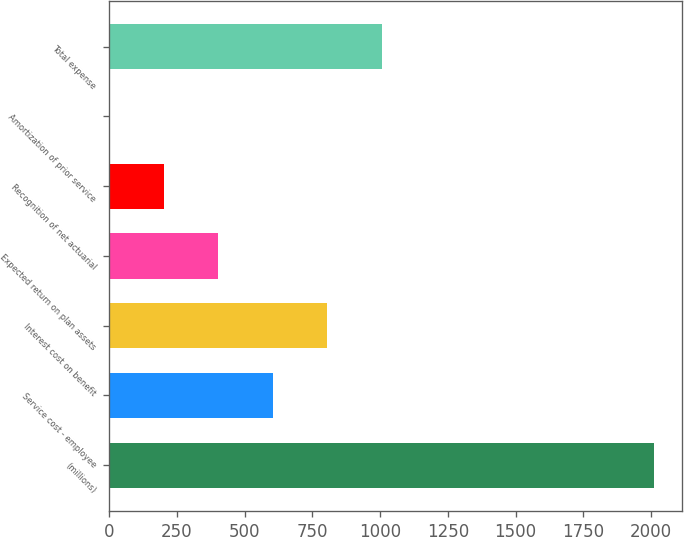Convert chart. <chart><loc_0><loc_0><loc_500><loc_500><bar_chart><fcel>(millions)<fcel>Service cost - employee<fcel>Interest cost on benefit<fcel>Expected return on plan assets<fcel>Recognition of net actuarial<fcel>Amortization of prior service<fcel>Total expense<nl><fcel>2013<fcel>604.11<fcel>805.38<fcel>402.84<fcel>201.57<fcel>0.3<fcel>1006.65<nl></chart> 